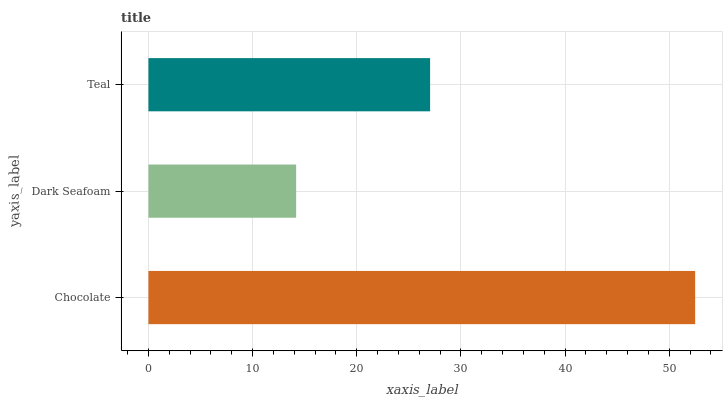Is Dark Seafoam the minimum?
Answer yes or no. Yes. Is Chocolate the maximum?
Answer yes or no. Yes. Is Teal the minimum?
Answer yes or no. No. Is Teal the maximum?
Answer yes or no. No. Is Teal greater than Dark Seafoam?
Answer yes or no. Yes. Is Dark Seafoam less than Teal?
Answer yes or no. Yes. Is Dark Seafoam greater than Teal?
Answer yes or no. No. Is Teal less than Dark Seafoam?
Answer yes or no. No. Is Teal the high median?
Answer yes or no. Yes. Is Teal the low median?
Answer yes or no. Yes. Is Dark Seafoam the high median?
Answer yes or no. No. Is Chocolate the low median?
Answer yes or no. No. 